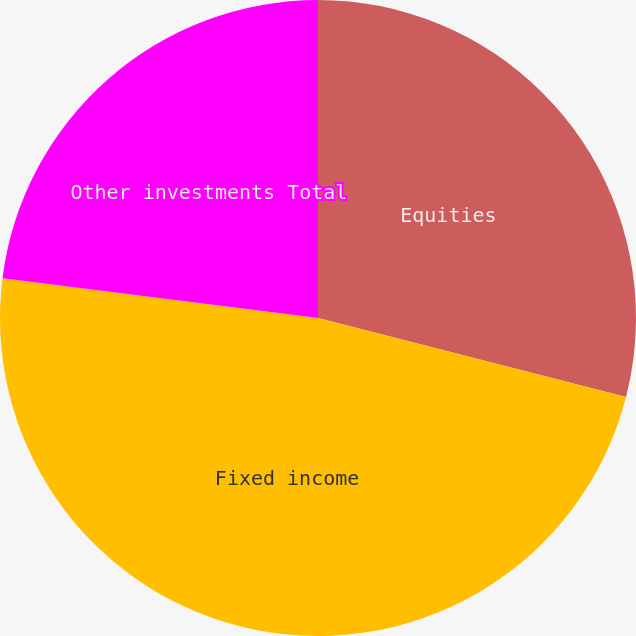Convert chart to OTSL. <chart><loc_0><loc_0><loc_500><loc_500><pie_chart><fcel>Equities<fcel>Fixed income<fcel>Other investments Total<nl><fcel>29.0%<fcel>48.0%<fcel>23.0%<nl></chart> 